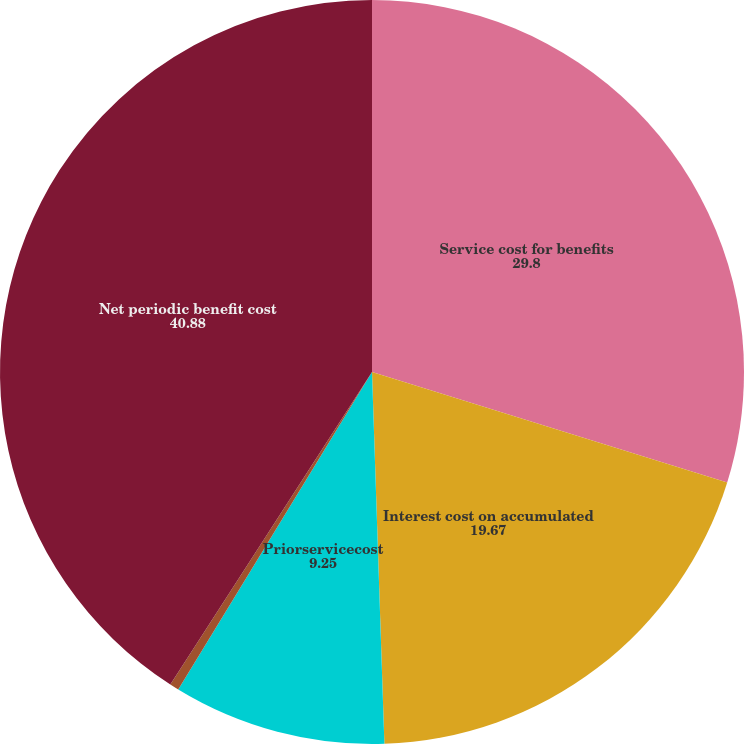<chart> <loc_0><loc_0><loc_500><loc_500><pie_chart><fcel>Service cost for benefits<fcel>Interest cost on accumulated<fcel>Priorservicecost<fcel>Actuarial loss<fcel>Net periodic benefit cost<nl><fcel>29.8%<fcel>19.67%<fcel>9.25%<fcel>0.4%<fcel>40.88%<nl></chart> 